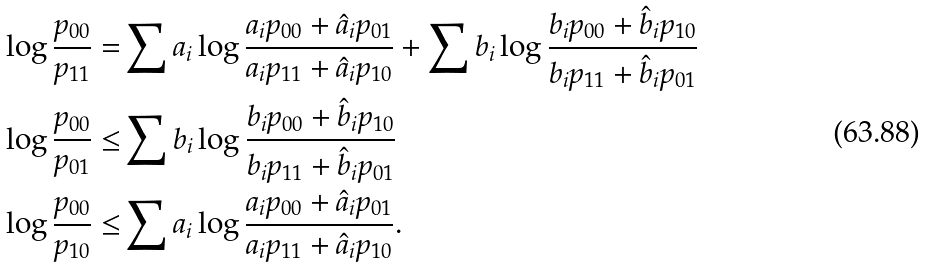Convert formula to latex. <formula><loc_0><loc_0><loc_500><loc_500>\log \frac { p _ { 0 0 } } { p _ { 1 1 } } = & \sum a _ { i } \log \frac { a _ { i } p _ { 0 0 } + \hat { a } _ { i } p _ { 0 1 } } { a _ { i } p _ { 1 1 } + \hat { a } _ { i } p _ { 1 0 } } + \sum b _ { i } \log \frac { b _ { i } p _ { 0 0 } + \hat { b } _ { i } p _ { 1 0 } } { b _ { i } p _ { 1 1 } + \hat { b } _ { i } p _ { 0 1 } } \\ \log \frac { p _ { 0 0 } } { p _ { 0 1 } } \leq & \sum b _ { i } \log \frac { b _ { i } p _ { 0 0 } + \hat { b } _ { i } p _ { 1 0 } } { b _ { i } p _ { 1 1 } + \hat { b } _ { i } p _ { 0 1 } } \\ \log \frac { p _ { 0 0 } } { p _ { 1 0 } } \leq & \sum a _ { i } \log \frac { a _ { i } p _ { 0 0 } + \hat { a } _ { i } p _ { 0 1 } } { a _ { i } p _ { 1 1 } + \hat { a } _ { i } p _ { 1 0 } } .</formula> 